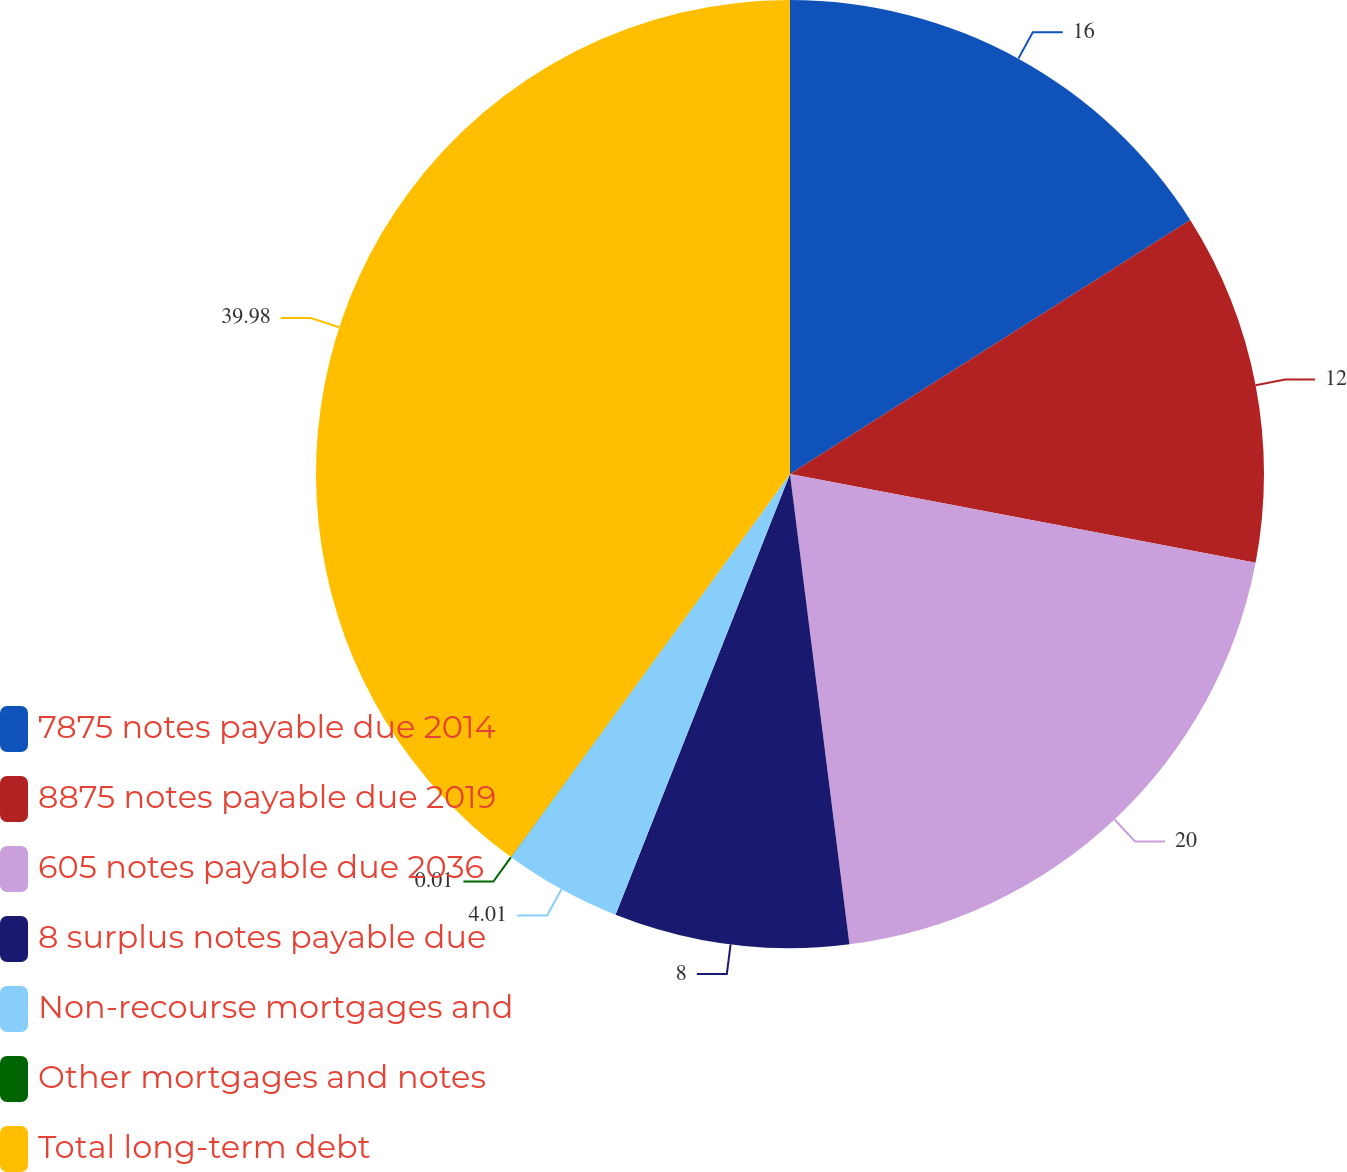<chart> <loc_0><loc_0><loc_500><loc_500><pie_chart><fcel>7875 notes payable due 2014<fcel>8875 notes payable due 2019<fcel>605 notes payable due 2036<fcel>8 surplus notes payable due<fcel>Non-recourse mortgages and<fcel>Other mortgages and notes<fcel>Total long-term debt<nl><fcel>16.0%<fcel>12.0%<fcel>20.0%<fcel>8.0%<fcel>4.01%<fcel>0.01%<fcel>39.98%<nl></chart> 